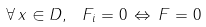Convert formula to latex. <formula><loc_0><loc_0><loc_500><loc_500>\forall \, x \in D , \ \, F _ { i } = 0 \, \Leftrightarrow \, F = 0</formula> 